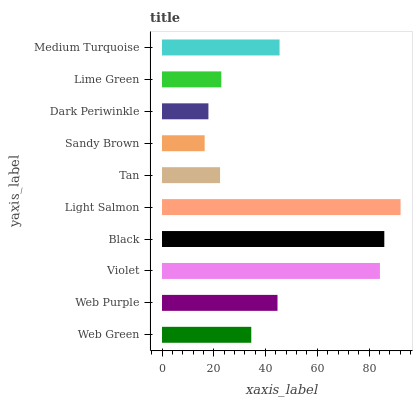Is Sandy Brown the minimum?
Answer yes or no. Yes. Is Light Salmon the maximum?
Answer yes or no. Yes. Is Web Purple the minimum?
Answer yes or no. No. Is Web Purple the maximum?
Answer yes or no. No. Is Web Purple greater than Web Green?
Answer yes or no. Yes. Is Web Green less than Web Purple?
Answer yes or no. Yes. Is Web Green greater than Web Purple?
Answer yes or no. No. Is Web Purple less than Web Green?
Answer yes or no. No. Is Web Purple the high median?
Answer yes or no. Yes. Is Web Green the low median?
Answer yes or no. Yes. Is Sandy Brown the high median?
Answer yes or no. No. Is Lime Green the low median?
Answer yes or no. No. 